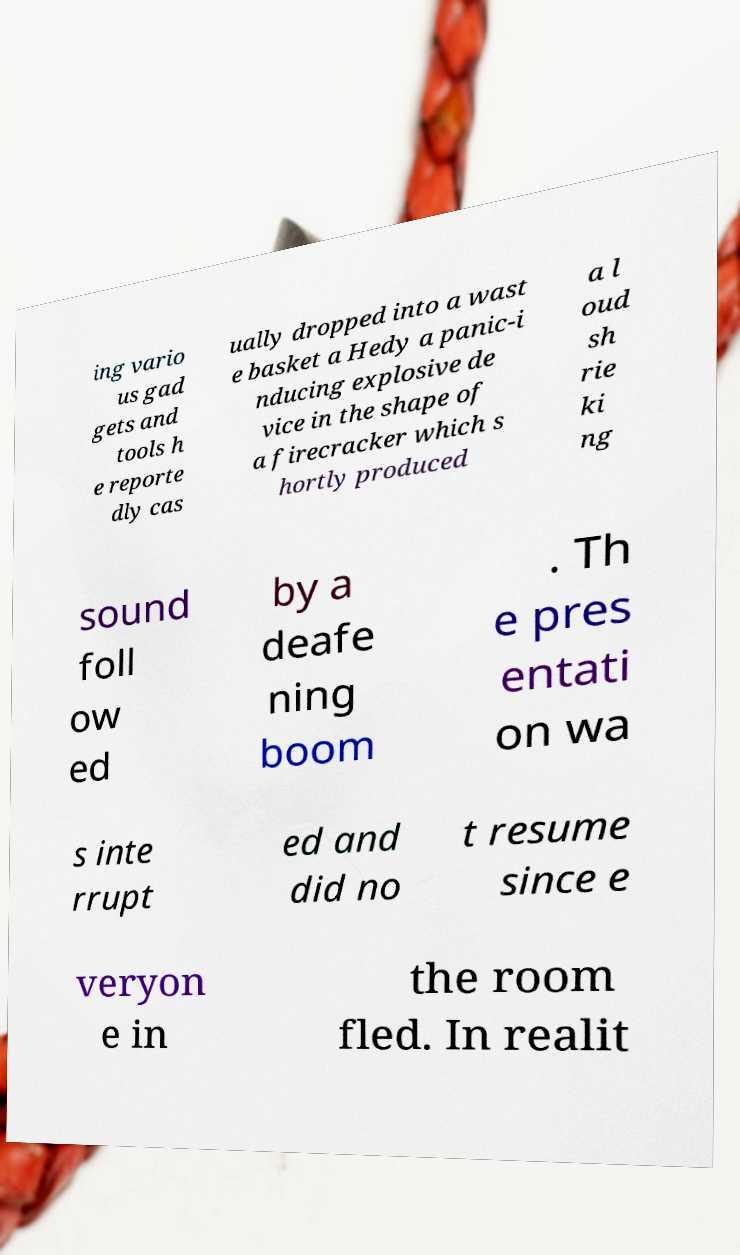Please read and relay the text visible in this image. What does it say? ing vario us gad gets and tools h e reporte dly cas ually dropped into a wast e basket a Hedy a panic-i nducing explosive de vice in the shape of a firecracker which s hortly produced a l oud sh rie ki ng sound foll ow ed by a deafe ning boom . Th e pres entati on wa s inte rrupt ed and did no t resume since e veryon e in the room fled. In realit 